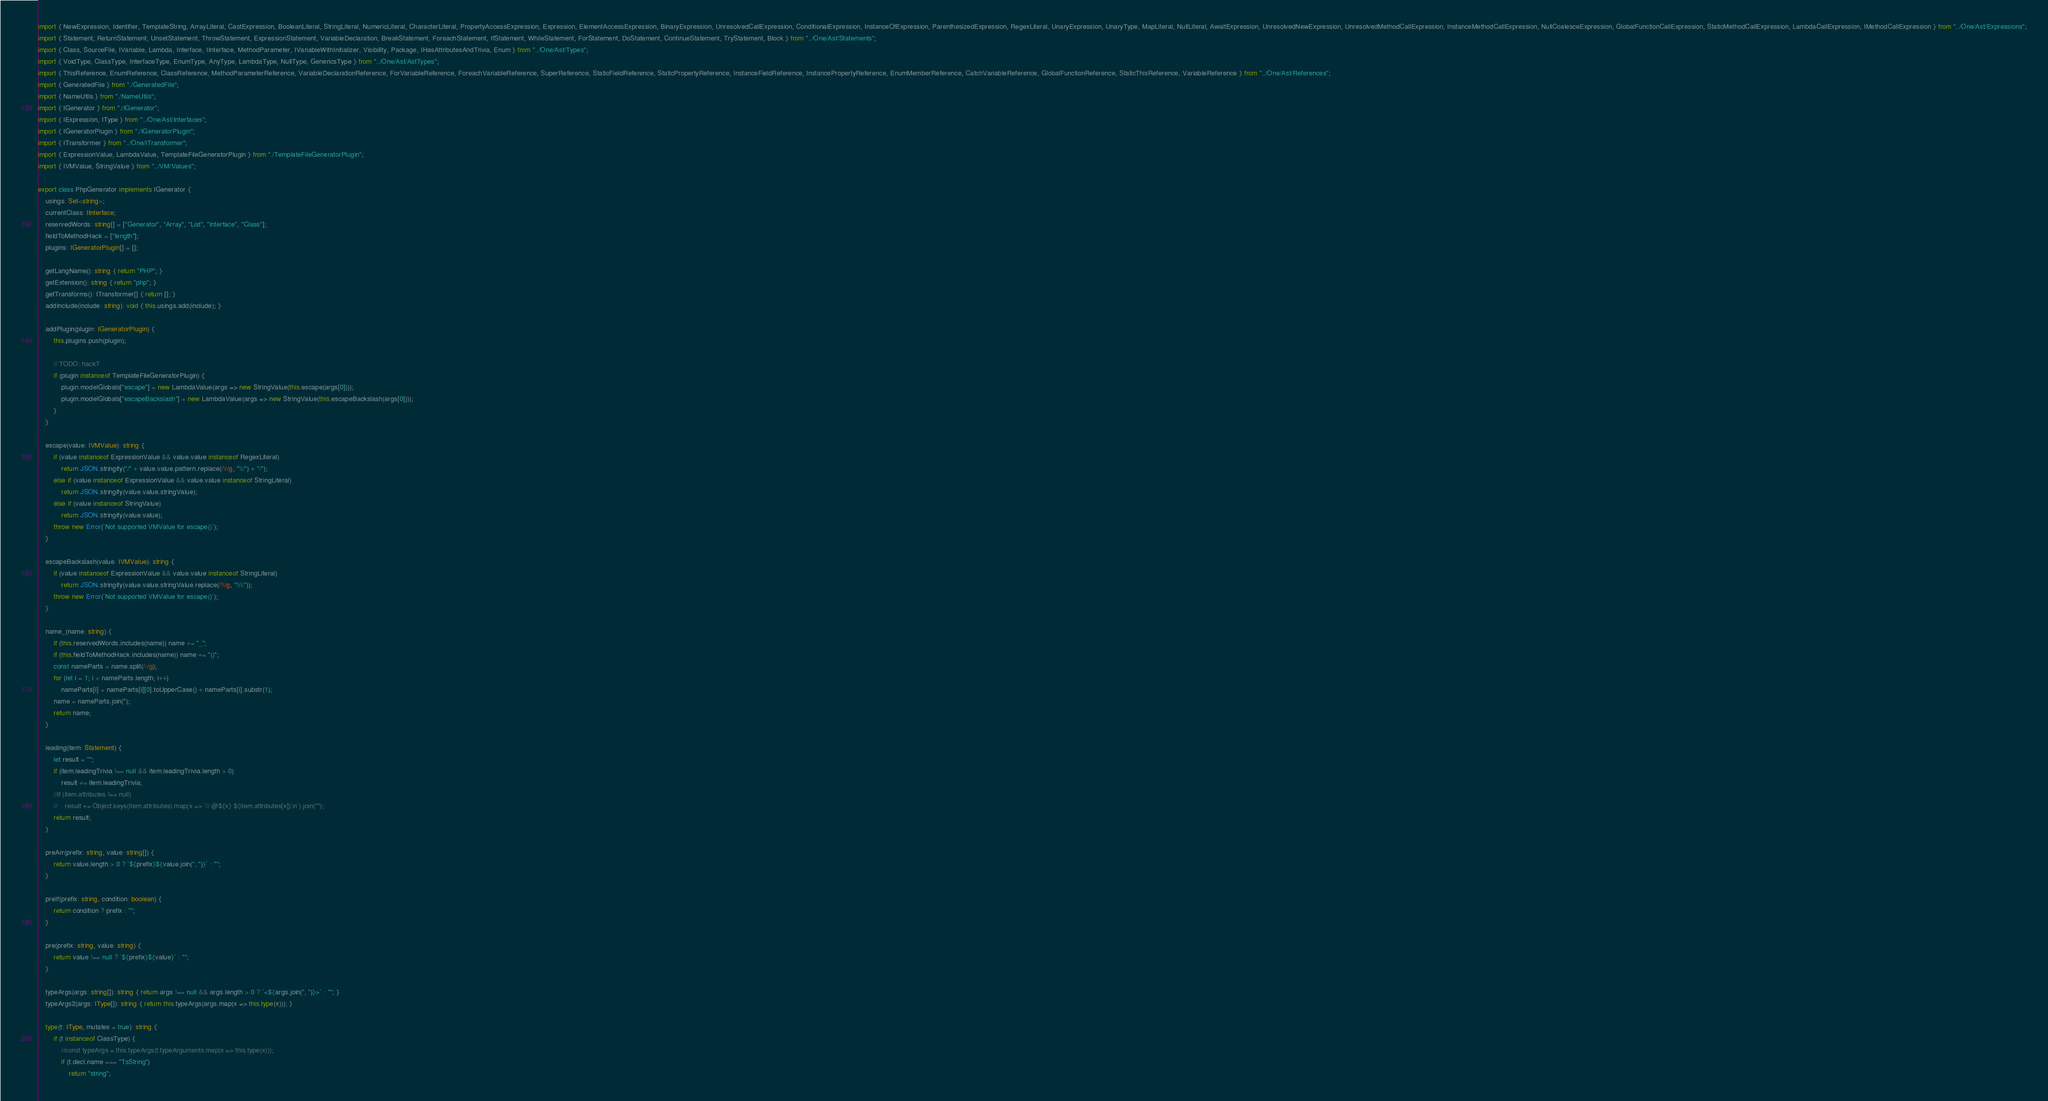<code> <loc_0><loc_0><loc_500><loc_500><_TypeScript_>import { NewExpression, Identifier, TemplateString, ArrayLiteral, CastExpression, BooleanLiteral, StringLiteral, NumericLiteral, CharacterLiteral, PropertyAccessExpression, Expression, ElementAccessExpression, BinaryExpression, UnresolvedCallExpression, ConditionalExpression, InstanceOfExpression, ParenthesizedExpression, RegexLiteral, UnaryExpression, UnaryType, MapLiteral, NullLiteral, AwaitExpression, UnresolvedNewExpression, UnresolvedMethodCallExpression, InstanceMethodCallExpression, NullCoalesceExpression, GlobalFunctionCallExpression, StaticMethodCallExpression, LambdaCallExpression, IMethodCallExpression } from "../One/Ast/Expressions";
import { Statement, ReturnStatement, UnsetStatement, ThrowStatement, ExpressionStatement, VariableDeclaration, BreakStatement, ForeachStatement, IfStatement, WhileStatement, ForStatement, DoStatement, ContinueStatement, TryStatement, Block } from "../One/Ast/Statements";
import { Class, SourceFile, IVariable, Lambda, Interface, IInterface, MethodParameter, IVariableWithInitializer, Visibility, Package, IHasAttributesAndTrivia, Enum } from "../One/Ast/Types";
import { VoidType, ClassType, InterfaceType, EnumType, AnyType, LambdaType, NullType, GenericsType } from "../One/Ast/AstTypes";
import { ThisReference, EnumReference, ClassReference, MethodParameterReference, VariableDeclarationReference, ForVariableReference, ForeachVariableReference, SuperReference, StaticFieldReference, StaticPropertyReference, InstanceFieldReference, InstancePropertyReference, EnumMemberReference, CatchVariableReference, GlobalFunctionReference, StaticThisReference, VariableReference } from "../One/Ast/References";
import { GeneratedFile } from "./GeneratedFile";
import { NameUtils } from "./NameUtils";
import { IGenerator } from "./IGenerator";
import { IExpression, IType } from "../One/Ast/Interfaces";
import { IGeneratorPlugin } from "./IGeneratorPlugin";
import { ITransformer } from "../One/ITransformer";
import { ExpressionValue, LambdaValue, TemplateFileGeneratorPlugin } from "./TemplateFileGeneratorPlugin";
import { IVMValue, StringValue } from "../VM/Values";

export class PhpGenerator implements IGenerator {
    usings: Set<string>;
    currentClass: IInterface;
    reservedWords: string[] = ["Generator", "Array", "List", "Interface", "Class"];
    fieldToMethodHack = ["length"];
    plugins: IGeneratorPlugin[] = [];

    getLangName(): string { return "PHP"; }
    getExtension(): string { return "php"; }
    getTransforms(): ITransformer[] { return []; }
    addInclude(include: string): void { this.usings.add(include); }

    addPlugin(plugin: IGeneratorPlugin) {
        this.plugins.push(plugin);

        // TODO: hack?
        if (plugin instanceof TemplateFileGeneratorPlugin) {
            plugin.modelGlobals["escape"] = new LambdaValue(args => new StringValue(this.escape(args[0])));
            plugin.modelGlobals["escapeBackslash"] = new LambdaValue(args => new StringValue(this.escapeBackslash(args[0])));
        }
    }

    escape(value: IVMValue): string {
        if (value instanceof ExpressionValue && value.value instanceof RegexLiteral)
            return JSON.stringify("/" + value.value.pattern.replace(/\//g, "\\/") + "/");
        else if (value instanceof ExpressionValue && value.value instanceof StringLiteral)
            return JSON.stringify(value.value.stringValue);
        else if (value instanceof StringValue)
            return JSON.stringify(value.value);
        throw new Error(`Not supported VMValue for escape()`);
    }

    escapeBackslash(value: IVMValue): string {
        if (value instanceof ExpressionValue && value.value instanceof StringLiteral)
            return JSON.stringify(value.value.stringValue.replace(/\\/g, "\\\\"));
        throw new Error(`Not supported VMValue for escape()`);
    }

    name_(name: string) {
        if (this.reservedWords.includes(name)) name += "_";
        if (this.fieldToMethodHack.includes(name)) name += "()";
        const nameParts = name.split(/-/g);
        for (let i = 1; i < nameParts.length; i++)
            nameParts[i] = nameParts[i][0].toUpperCase() + nameParts[i].substr(1);
        name = nameParts.join('');
        return name;
    }

    leading(item: Statement) {
        let result = "";
        if (item.leadingTrivia !== null && item.leadingTrivia.length > 0)
            result += item.leadingTrivia;
        //if (item.attributes !== null)
        //    result += Object.keys(item.attributes).map(x => `// @${x} ${item.attributes[x]}\n`).join("");
        return result;
    }

    preArr(prefix: string, value: string[]) {
        return value.length > 0 ? `${prefix}${value.join(", ")}` : "";
    }

    preIf(prefix: string, condition: boolean) {
        return condition ? prefix : "";
    }

    pre(prefix: string, value: string) {
        return value !== null ? `${prefix}${value}` : "";
    }

    typeArgs(args: string[]): string { return args !== null && args.length > 0 ? `<${args.join(", ")}>` : ""; }
    typeArgs2(args: IType[]): string { return this.typeArgs(args.map(x => this.type(x))); }

    type(t: IType, mutates = true): string {
        if (t instanceof ClassType) {
            //const typeArgs = this.typeArgs(t.typeArguments.map(x => this.type(x)));
            if (t.decl.name === "TsString")
                return "string";</code> 